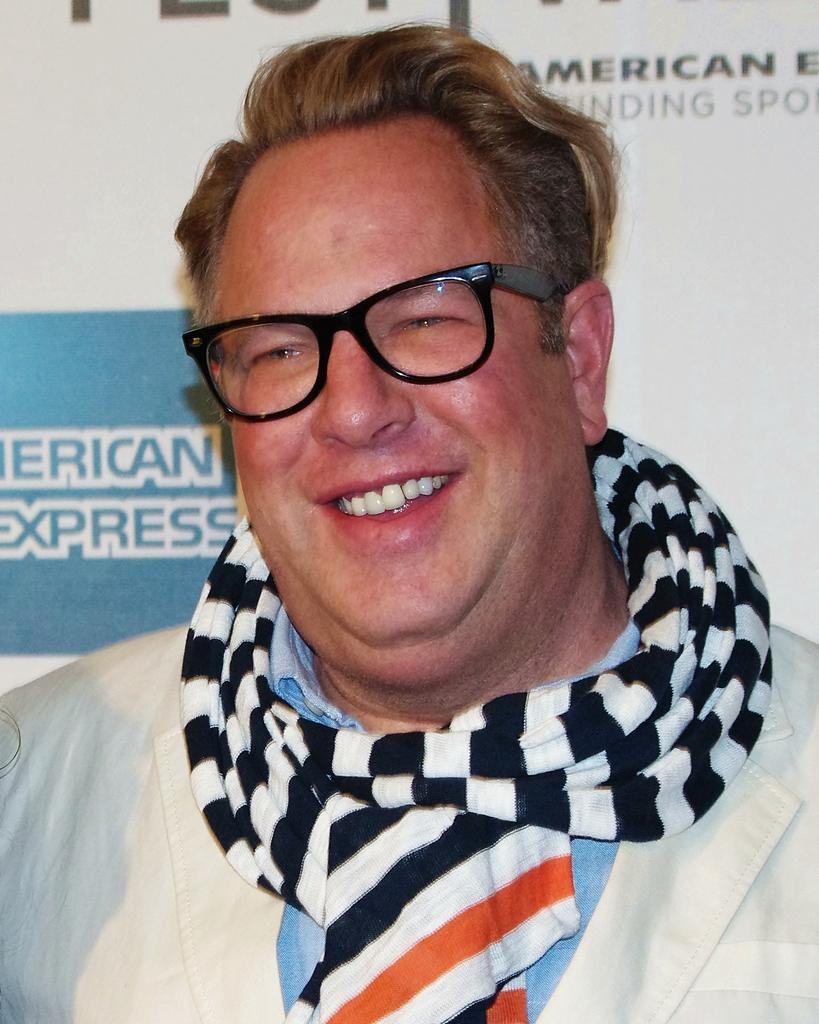Who is present in the image? There is a man in the image. What is the man doing in the image? The man is smiling in the image. What accessory is the man wearing in the image? The man is wearing spectacles in the image. What can be seen in the background of the image? There is a banner in the background of the image. What type of rain apparel is the man wearing in the image? There is no rain apparel present in the image; the man is wearing spectacles, but no specific mention of rain apparel is made. 